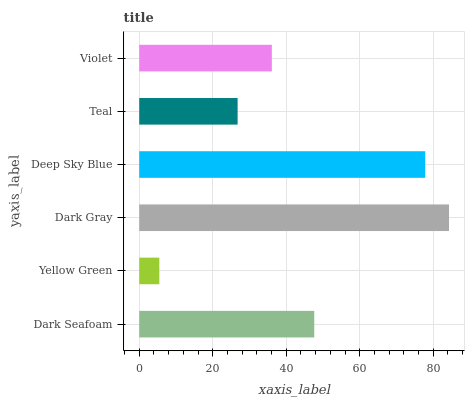Is Yellow Green the minimum?
Answer yes or no. Yes. Is Dark Gray the maximum?
Answer yes or no. Yes. Is Dark Gray the minimum?
Answer yes or no. No. Is Yellow Green the maximum?
Answer yes or no. No. Is Dark Gray greater than Yellow Green?
Answer yes or no. Yes. Is Yellow Green less than Dark Gray?
Answer yes or no. Yes. Is Yellow Green greater than Dark Gray?
Answer yes or no. No. Is Dark Gray less than Yellow Green?
Answer yes or no. No. Is Dark Seafoam the high median?
Answer yes or no. Yes. Is Violet the low median?
Answer yes or no. Yes. Is Yellow Green the high median?
Answer yes or no. No. Is Dark Seafoam the low median?
Answer yes or no. No. 